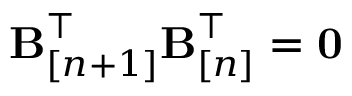<formula> <loc_0><loc_0><loc_500><loc_500>{ B } _ { [ n + 1 ] } ^ { \top } { B } _ { [ n ] } ^ { \top } = { 0 }</formula> 